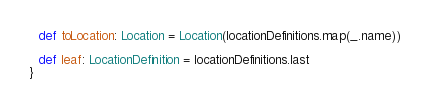Convert code to text. <code><loc_0><loc_0><loc_500><loc_500><_Scala_>
  def toLocation: Location = Location(locationDefinitions.map(_.name))

  def leaf: LocationDefinition = locationDefinitions.last
}
</code> 